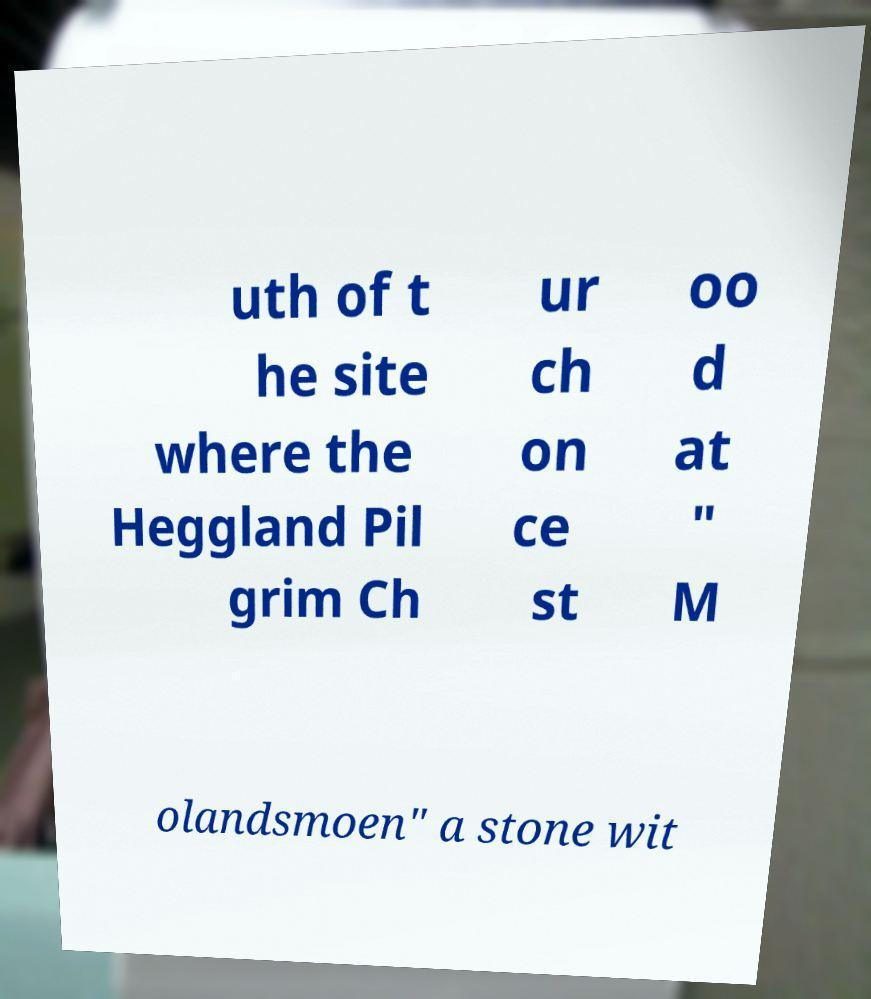Please identify and transcribe the text found in this image. uth of t he site where the Heggland Pil grim Ch ur ch on ce st oo d at " M olandsmoen" a stone wit 